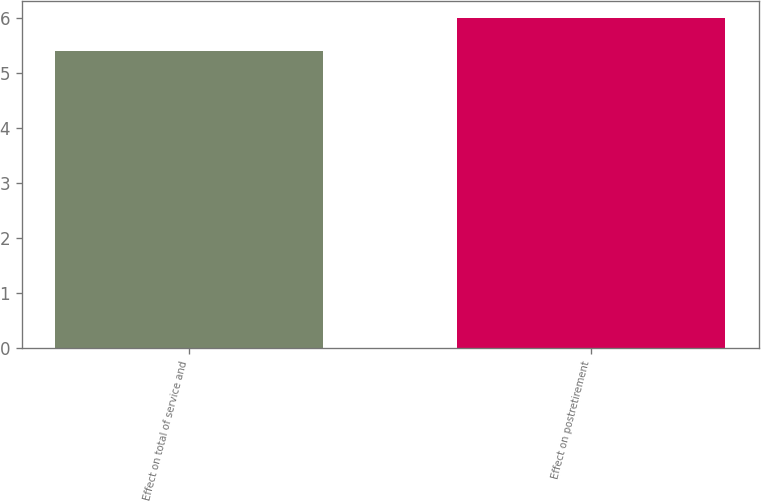Convert chart to OTSL. <chart><loc_0><loc_0><loc_500><loc_500><bar_chart><fcel>Effect on total of service and<fcel>Effect on postretirement<nl><fcel>5.4<fcel>6<nl></chart> 